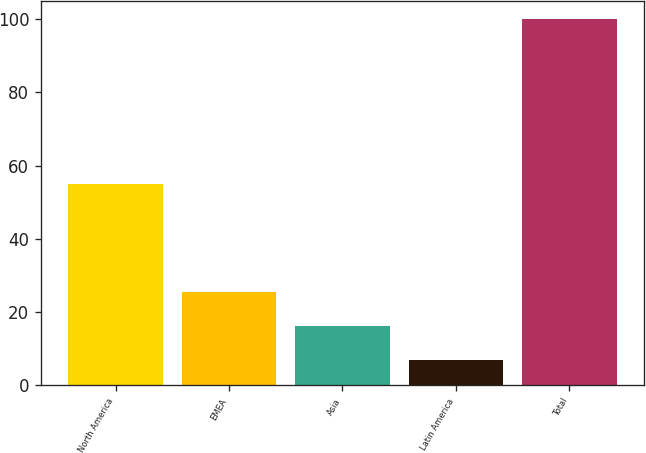Convert chart. <chart><loc_0><loc_0><loc_500><loc_500><bar_chart><fcel>North America<fcel>EMEA<fcel>Asia<fcel>Latin America<fcel>Total<nl><fcel>55<fcel>25.6<fcel>16.3<fcel>7<fcel>100<nl></chart> 